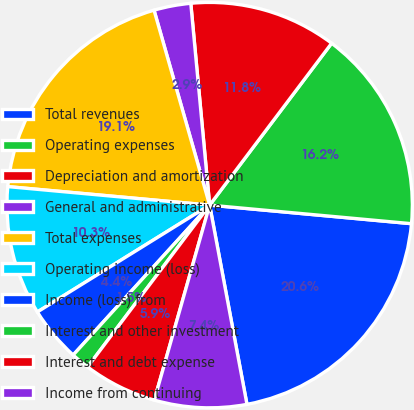Convert chart. <chart><loc_0><loc_0><loc_500><loc_500><pie_chart><fcel>Total revenues<fcel>Operating expenses<fcel>Depreciation and amortization<fcel>General and administrative<fcel>Total expenses<fcel>Operating income (loss)<fcel>Income (loss) from<fcel>Interest and other investment<fcel>Interest and debt expense<fcel>Income from continuing<nl><fcel>20.59%<fcel>16.18%<fcel>11.76%<fcel>2.94%<fcel>19.12%<fcel>10.29%<fcel>4.41%<fcel>1.47%<fcel>5.88%<fcel>7.35%<nl></chart> 